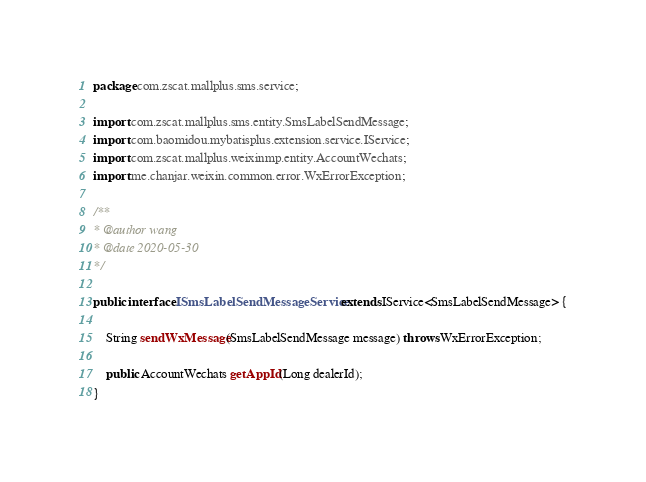Convert code to text. <code><loc_0><loc_0><loc_500><loc_500><_Java_>package com.zscat.mallplus.sms.service;

import com.zscat.mallplus.sms.entity.SmsLabelSendMessage;
import com.baomidou.mybatisplus.extension.service.IService;
import com.zscat.mallplus.weixinmp.entity.AccountWechats;
import me.chanjar.weixin.common.error.WxErrorException;

/**
* @author wang
* @date 2020-05-30
*/

public interface ISmsLabelSendMessageService extends IService<SmsLabelSendMessage> {

    String sendWxMessage(SmsLabelSendMessage message) throws WxErrorException;

    public AccountWechats getAppId(Long dealerId);
}
</code> 